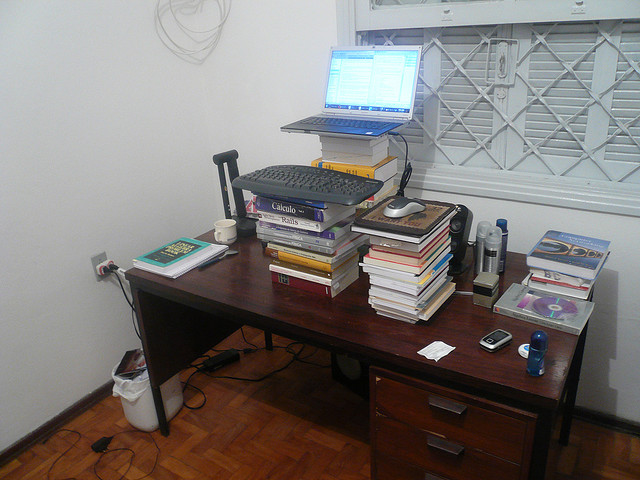Identify the text displayed in this image. Calculo 